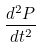Convert formula to latex. <formula><loc_0><loc_0><loc_500><loc_500>\frac { d ^ { 2 } P } { d t ^ { 2 } }</formula> 